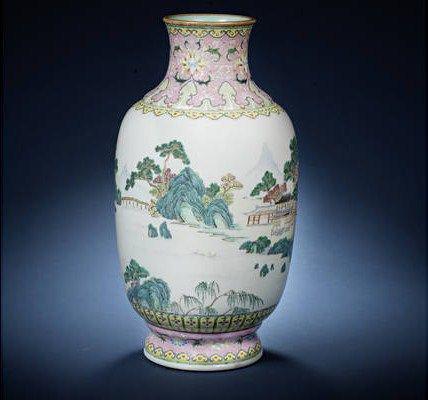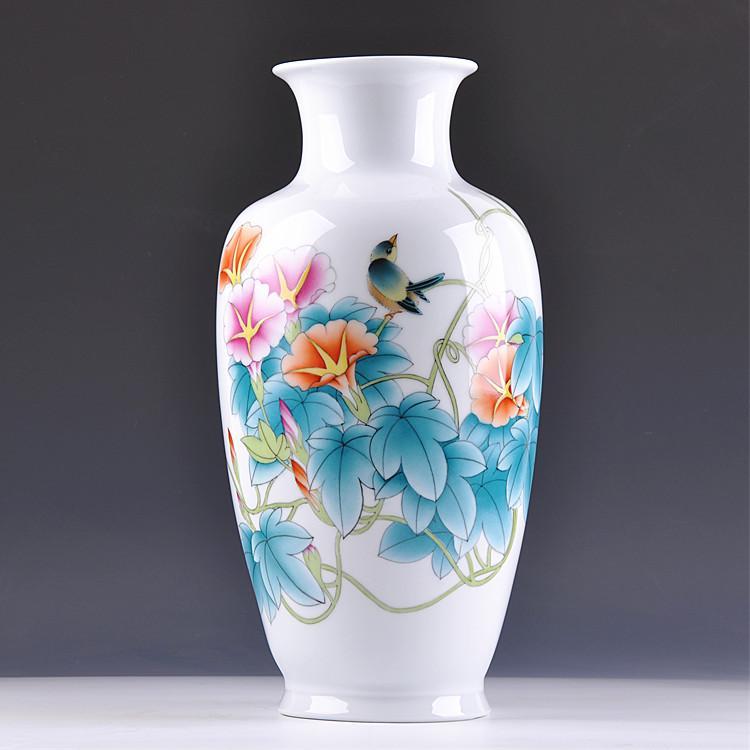The first image is the image on the left, the second image is the image on the right. For the images displayed, is the sentence "In at least one image there is a all blue and white vase with a circular middle." factually correct? Answer yes or no. No. The first image is the image on the left, the second image is the image on the right. Evaluate the accuracy of this statement regarding the images: "One ceramic vase features floral motifs and only blue and white colors, and the other vase has a narrow neck with a wider round bottom and includes pink flowers as decoration.". Is it true? Answer yes or no. No. 